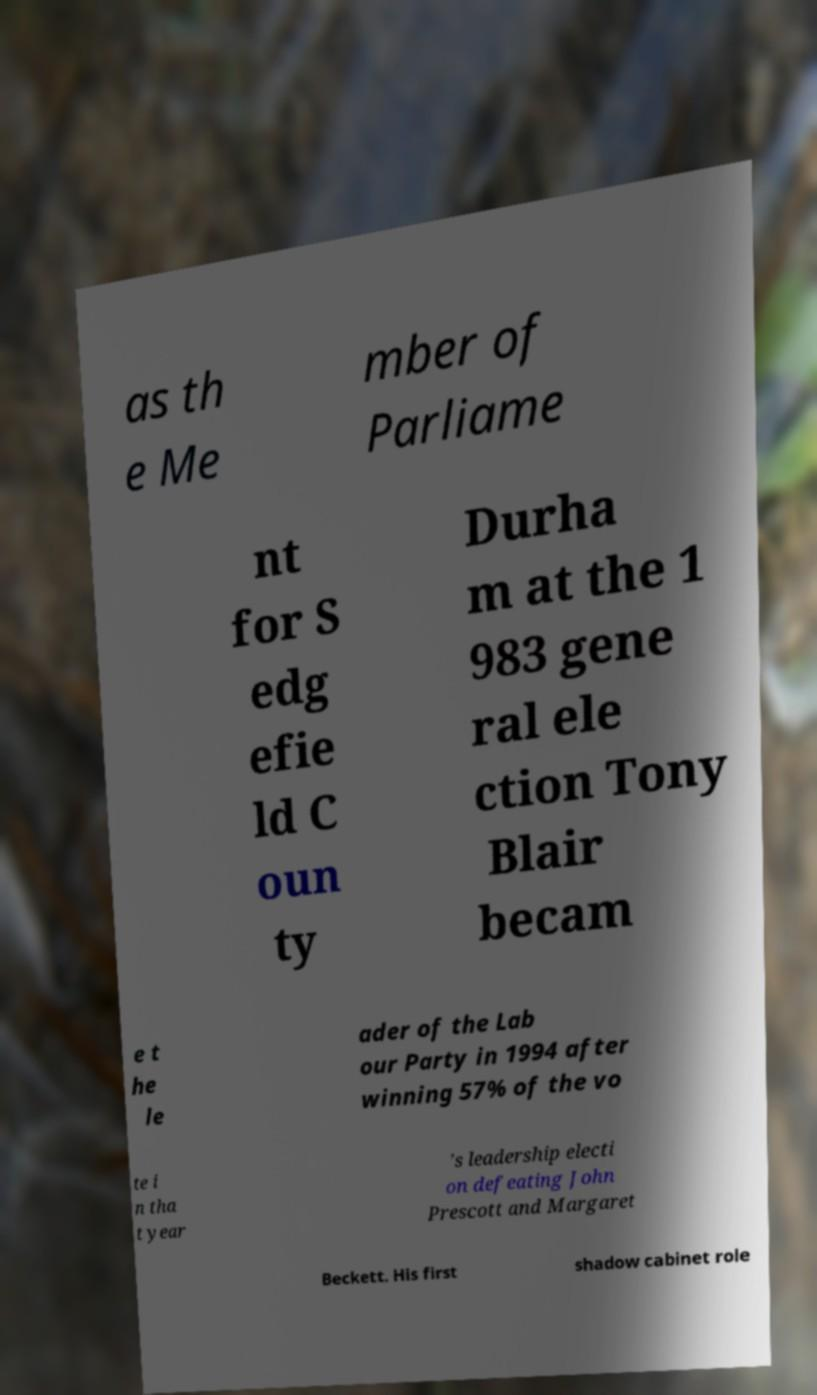I need the written content from this picture converted into text. Can you do that? as th e Me mber of Parliame nt for S edg efie ld C oun ty Durha m at the 1 983 gene ral ele ction Tony Blair becam e t he le ader of the Lab our Party in 1994 after winning 57% of the vo te i n tha t year 's leadership electi on defeating John Prescott and Margaret Beckett. His first shadow cabinet role 